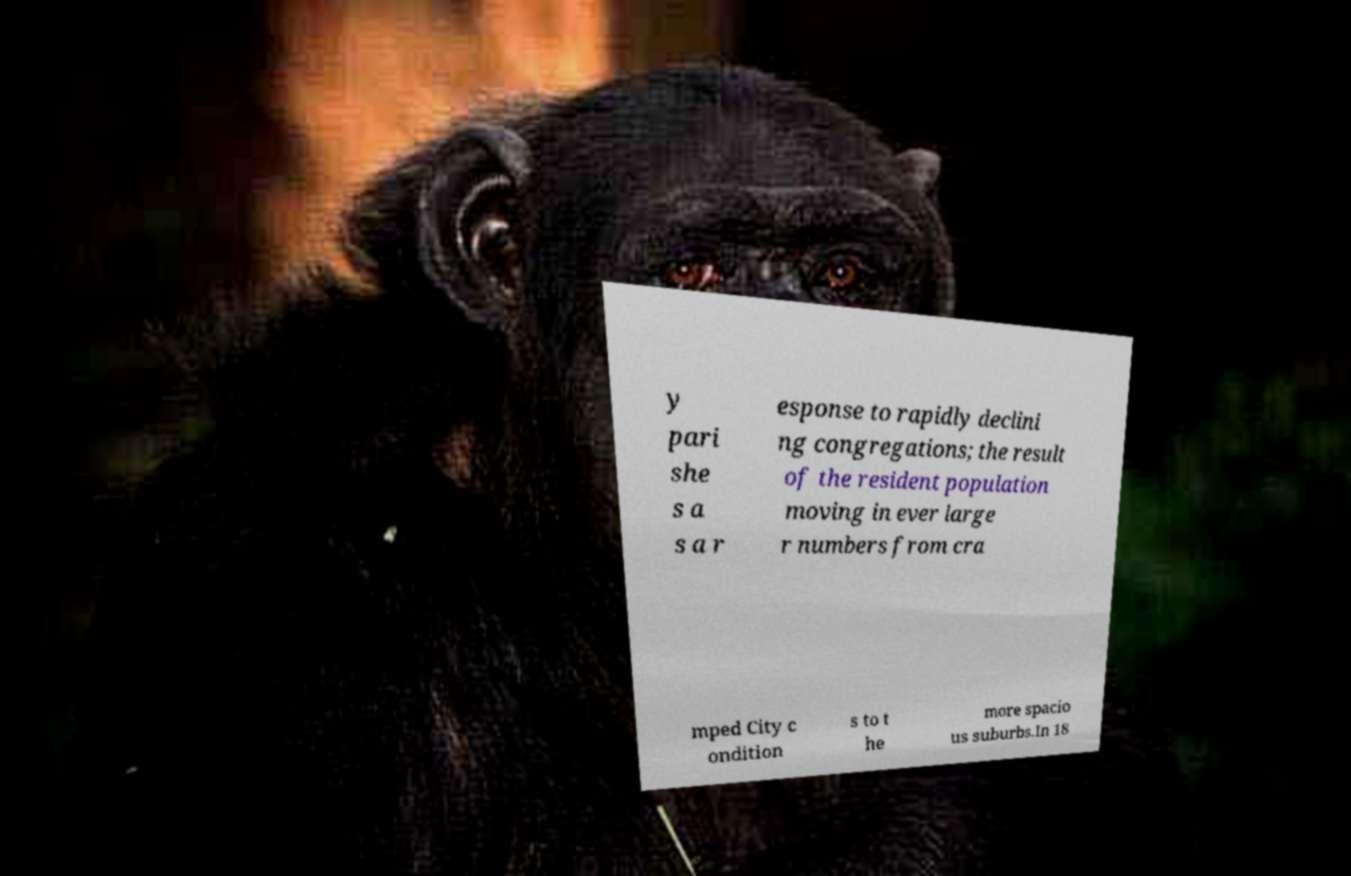Can you read and provide the text displayed in the image?This photo seems to have some interesting text. Can you extract and type it out for me? y pari she s a s a r esponse to rapidly declini ng congregations; the result of the resident population moving in ever large r numbers from cra mped City c ondition s to t he more spacio us suburbs.In 18 